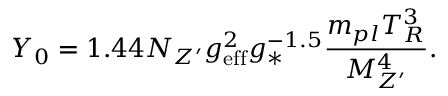<formula> <loc_0><loc_0><loc_500><loc_500>Y _ { 0 } = 1 . 4 4 N _ { Z ^ { \prime } } g _ { e f f } ^ { 2 } g _ { * } ^ { - 1 . 5 } \frac { m _ { p l } T _ { R } ^ { 3 } } { M _ { Z ^ { \prime } } ^ { 4 } } .</formula> 